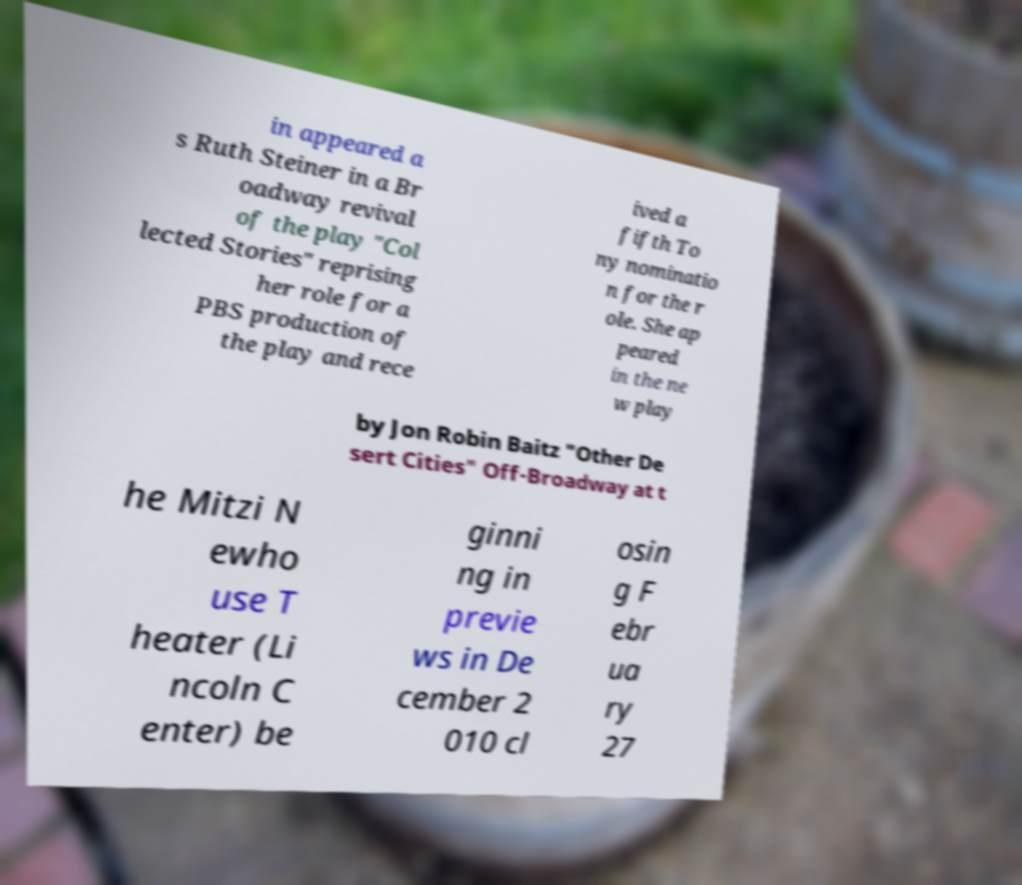Please read and relay the text visible in this image. What does it say? in appeared a s Ruth Steiner in a Br oadway revival of the play "Col lected Stories" reprising her role for a PBS production of the play and rece ived a fifth To ny nominatio n for the r ole. She ap peared in the ne w play by Jon Robin Baitz "Other De sert Cities" Off-Broadway at t he Mitzi N ewho use T heater (Li ncoln C enter) be ginni ng in previe ws in De cember 2 010 cl osin g F ebr ua ry 27 